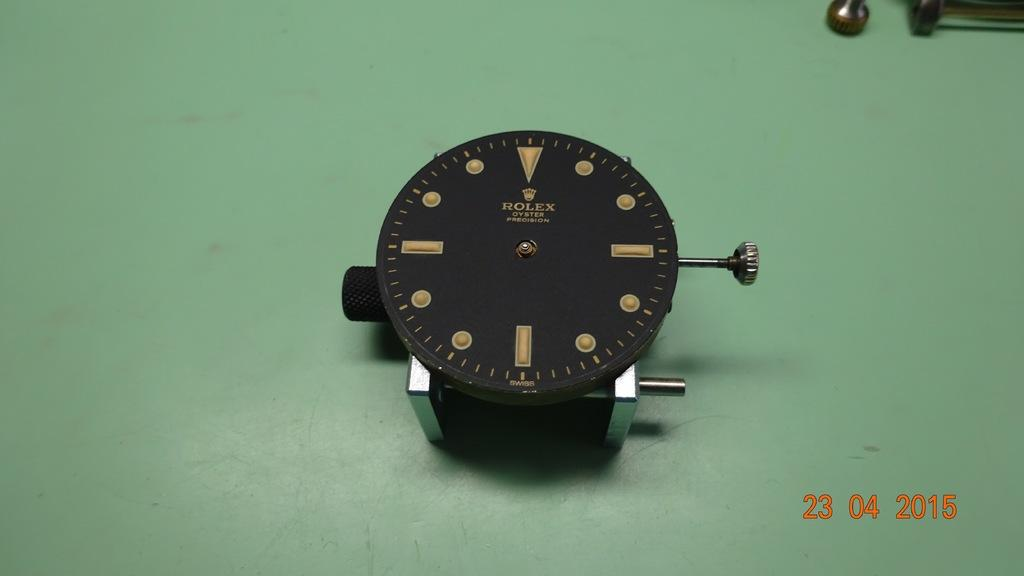<image>
Render a clear and concise summary of the photo. Black wrist watch that says ROLEX on the face. 